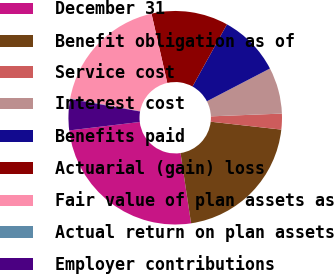Convert chart to OTSL. <chart><loc_0><loc_0><loc_500><loc_500><pie_chart><fcel>December 31<fcel>Benefit obligation as of<fcel>Service cost<fcel>Interest cost<fcel>Benefits paid<fcel>Actuarial (gain) loss<fcel>Fair value of plan assets as<fcel>Actual return on plan assets<fcel>Employer contributions<nl><fcel>25.48%<fcel>20.86%<fcel>2.39%<fcel>7.01%<fcel>9.32%<fcel>11.62%<fcel>18.55%<fcel>0.08%<fcel>4.7%<nl></chart> 